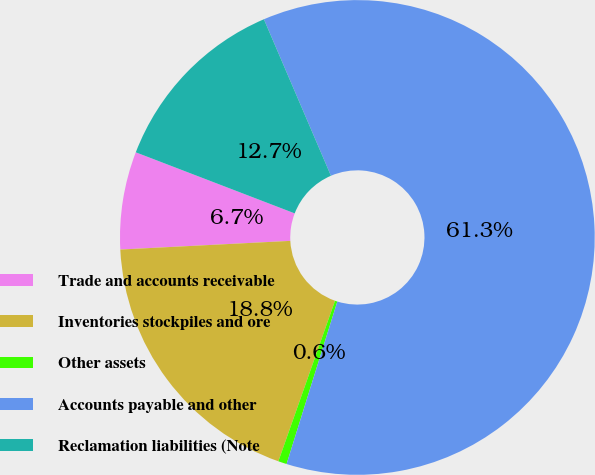Convert chart. <chart><loc_0><loc_0><loc_500><loc_500><pie_chart><fcel>Trade and accounts receivable<fcel>Inventories stockpiles and ore<fcel>Other assets<fcel>Accounts payable and other<fcel>Reclamation liabilities (Note<nl><fcel>6.65%<fcel>18.79%<fcel>0.58%<fcel>61.26%<fcel>12.72%<nl></chart> 